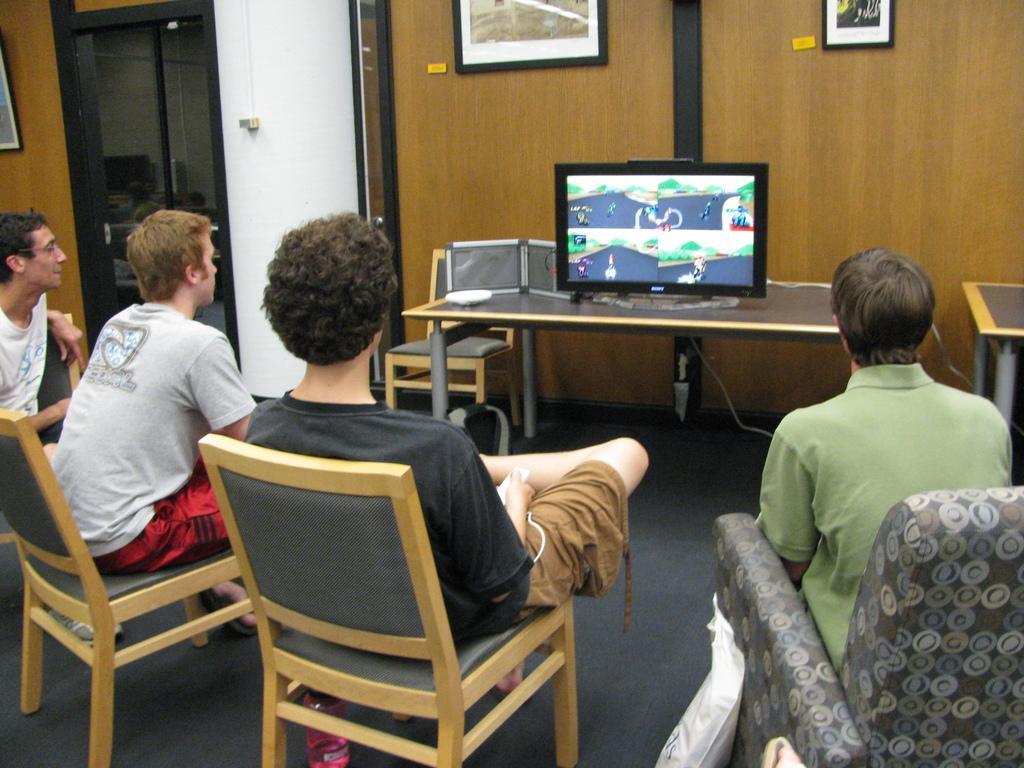Can you describe this image briefly? In this picture we can see four persons sitting on chairs and looking at television which is placed on table and in background we can see door, wall, frames. 